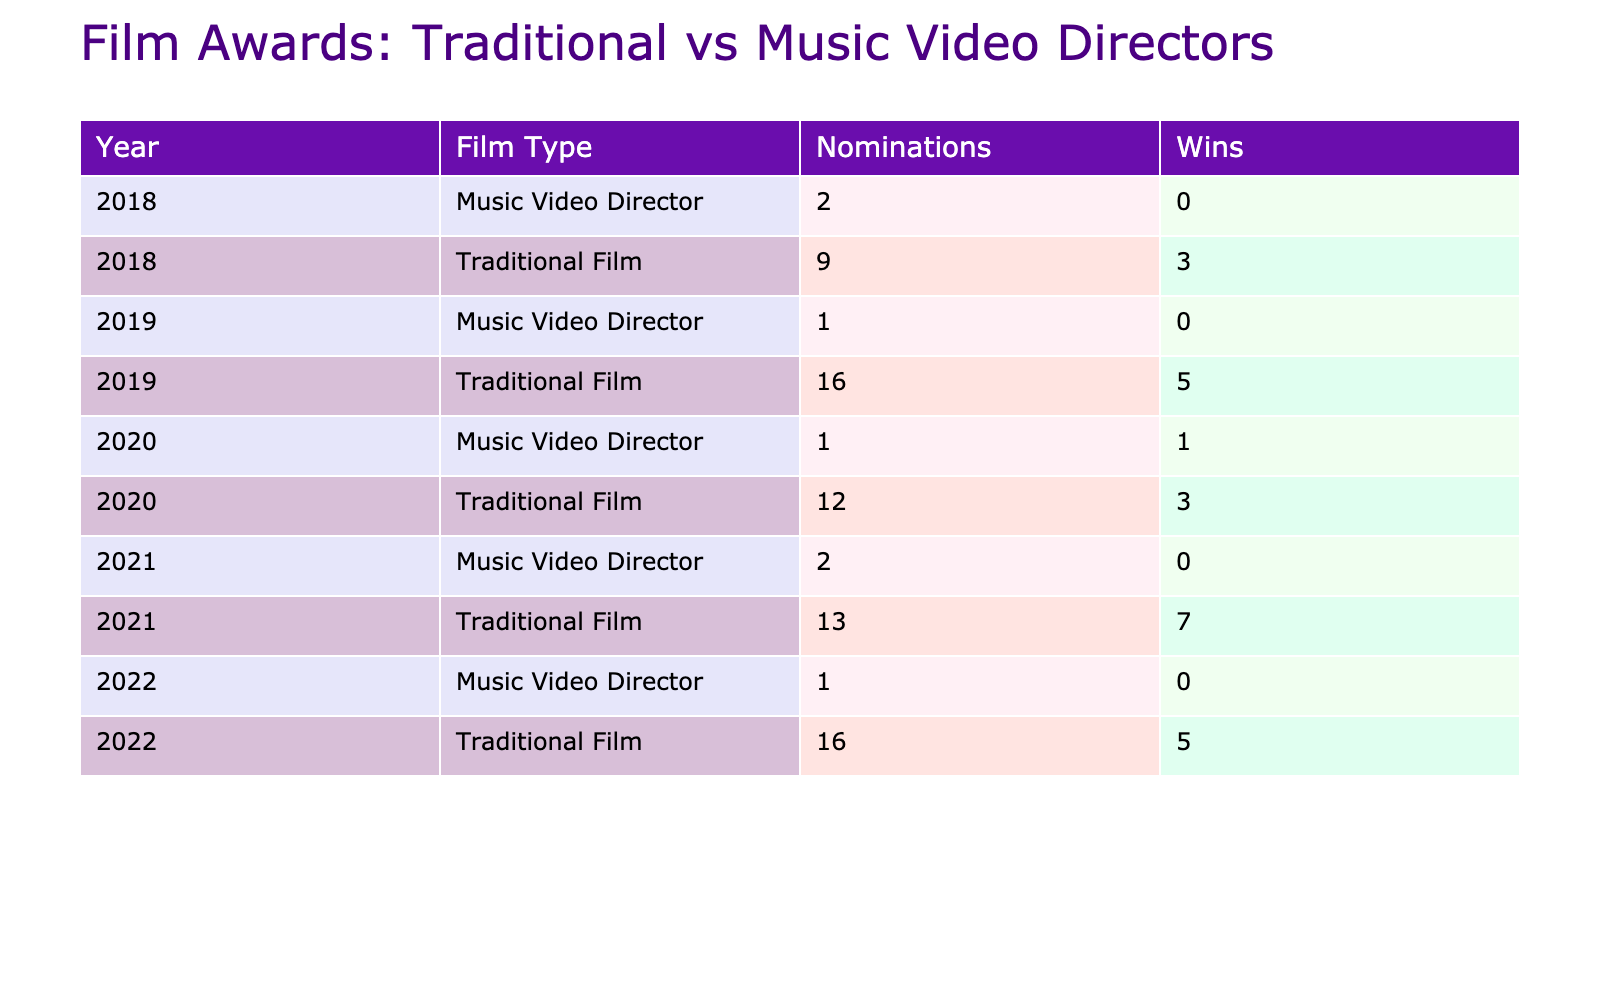What is the total number of nominations received by traditional film directors in 2019? In 2019, the nominations for traditional film directors are: Christopher Nolan with 6 and Quentin Tarantino with 10. Adding these nominations gives us 6 + 10 = 16.
Answer: 16 What is the highest number of wins achieved by a music video director's feature film according to the table? The music video director with the highest number of wins is Mark Romanek in 2020, who won 1 award. No other music video directors listed have any wins.
Answer: 1 Did any music video director win an Academy Award? Referring to the table, Spike Jonze and Jonathan Glazer, both music video directors, have 0 wins at the Academy Awards. Therefore, none of the music video directors have won this particular award.
Answer: No Which traditional film director had the most nominations in 2022? In 2022, Jane Campion had the highest nominations with 12 at the Academy Awards. Guillermo del Toro followed with 4 nominations. Thus, Jane Campion had the most.
Answer: 12 What is the difference in the number of wins between traditional film directors and music video directors in 2021? In 2021, Denis Villeneuve won 6 awards and Paul Thomas Anderson won 1 award for traditional films, summing up to 6 + 1 = 7. Meanwhile, Jonathan Glazer, the music video director, had 0 wins. The difference is 7 - 0 = 7.
Answer: 7 How many films received nominations from music video directors in total? Spike Jonze received 2 nominations in 2018, Michel Gondry received 1 in 2019, and Jonathan Glazer received 2 in 2021, totaling 2 + 1 + 2 = 5 nominations from music video directors.
Answer: 5 What percentage of nominations for traditional films resulted in wins in 2020? In 2020, total nominations for traditional film directors were 7 (Spielberg) + 5 (Anderson) = 12. Wins were 1 (Spielberg) + 2 (Anderson) = 3. The percentage is calculated as (3/12) * 100 = 25%.
Answer: 25% How many total wins did traditional film directors secure across all years listed in the table? Summing the wins for traditional films: 1 (Scorsese) + 2 (Fincher) + 3 (Nolan) + 2 (Tarantino) + 1 (Spielberg) + 2 (Anderson) + 6 (Villeneuve) + 3 (Campion) + 2 (del Toro) equals 19.
Answer: 19 Was there any traditional film director who received nominations in every year listed? By examining each year, only traditional film directors are Martin Scorsese (2018), Christopher Nolan (2019), Steven Spielberg (2020), Denis Villeneuve (2021), Jane Campion (2022), and Guillermo del Toro (2022) showed consistent nominations. However, not every director was nominated each year, therefore no director received nominations in every year.
Answer: No 